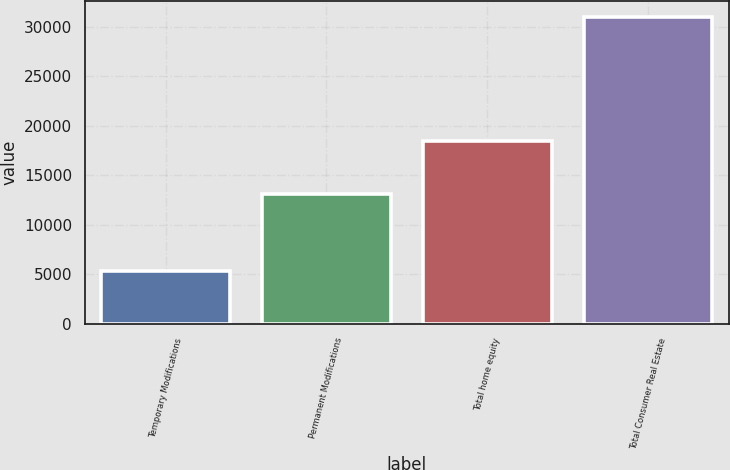Convert chart to OTSL. <chart><loc_0><loc_0><loc_500><loc_500><bar_chart><fcel>Temporary Modifications<fcel>Permanent Modifications<fcel>Total home equity<fcel>Total Consumer Real Estate<nl><fcel>5346<fcel>13128<fcel>18474<fcel>31000<nl></chart> 